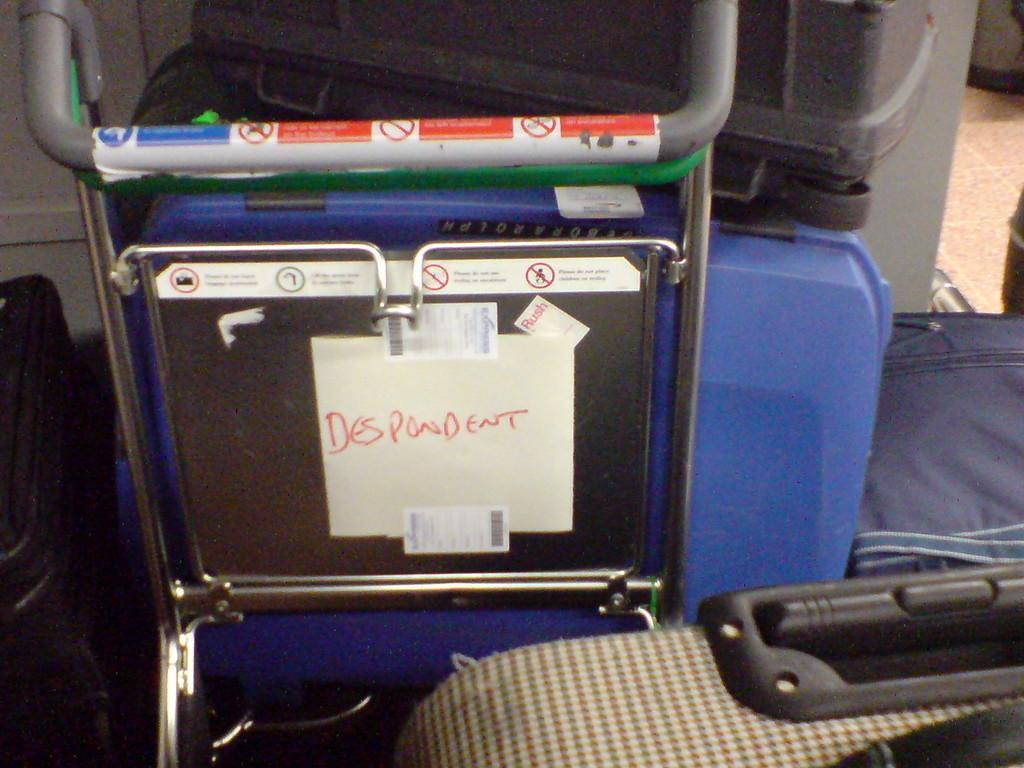Can you describe this image briefly? This is a cart. On this chart there are some luggage. Also on the cart there are some stickers and notices posted. 